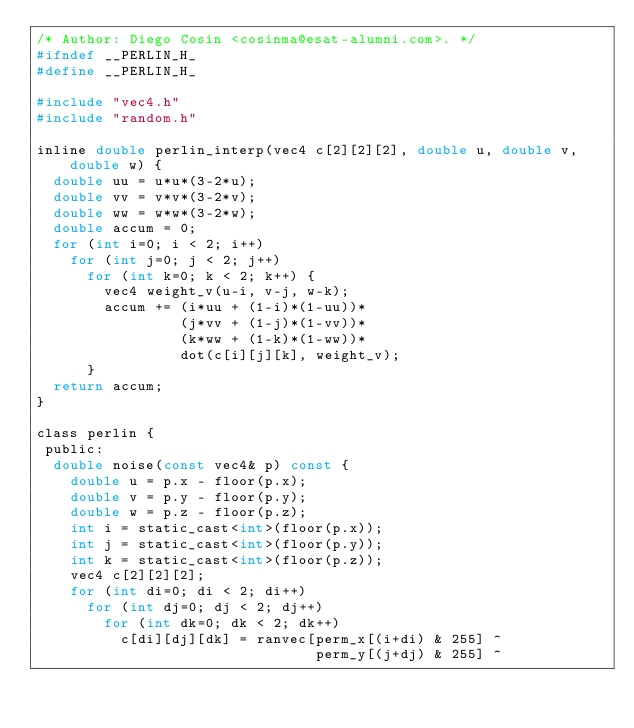Convert code to text. <code><loc_0><loc_0><loc_500><loc_500><_C_>/* Author: Diego Cosin <cosinma@esat-alumni.com>. */
#ifndef __PERLIN_H_
#define __PERLIN_H_

#include "vec4.h"
#include "random.h"

inline double perlin_interp(vec4 c[2][2][2], double u, double v, double w) {
  double uu = u*u*(3-2*u);
  double vv = v*v*(3-2*v);
  double ww = w*w*(3-2*w);
  double accum = 0;
  for (int i=0; i < 2; i++)
    for (int j=0; j < 2; j++)
      for (int k=0; k < 2; k++) {
        vec4 weight_v(u-i, v-j, w-k);
        accum += (i*uu + (1-i)*(1-uu))*
                 (j*vv + (1-j)*(1-vv))*
                 (k*ww + (1-k)*(1-ww))*
                 dot(c[i][j][k], weight_v);
      }
  return accum;
}

class perlin {
 public:
  double noise(const vec4& p) const {
    double u = p.x - floor(p.x);
    double v = p.y - floor(p.y);
    double w = p.z - floor(p.z);
    int i = static_cast<int>(floor(p.x));
    int j = static_cast<int>(floor(p.y));
    int k = static_cast<int>(floor(p.z));
    vec4 c[2][2][2];
    for (int di=0; di < 2; di++)
      for (int dj=0; dj < 2; dj++)
        for (int dk=0; dk < 2; dk++)
          c[di][dj][dk] = ranvec[perm_x[(i+di) & 255] ^
                                 perm_y[(j+dj) & 255] ^</code> 